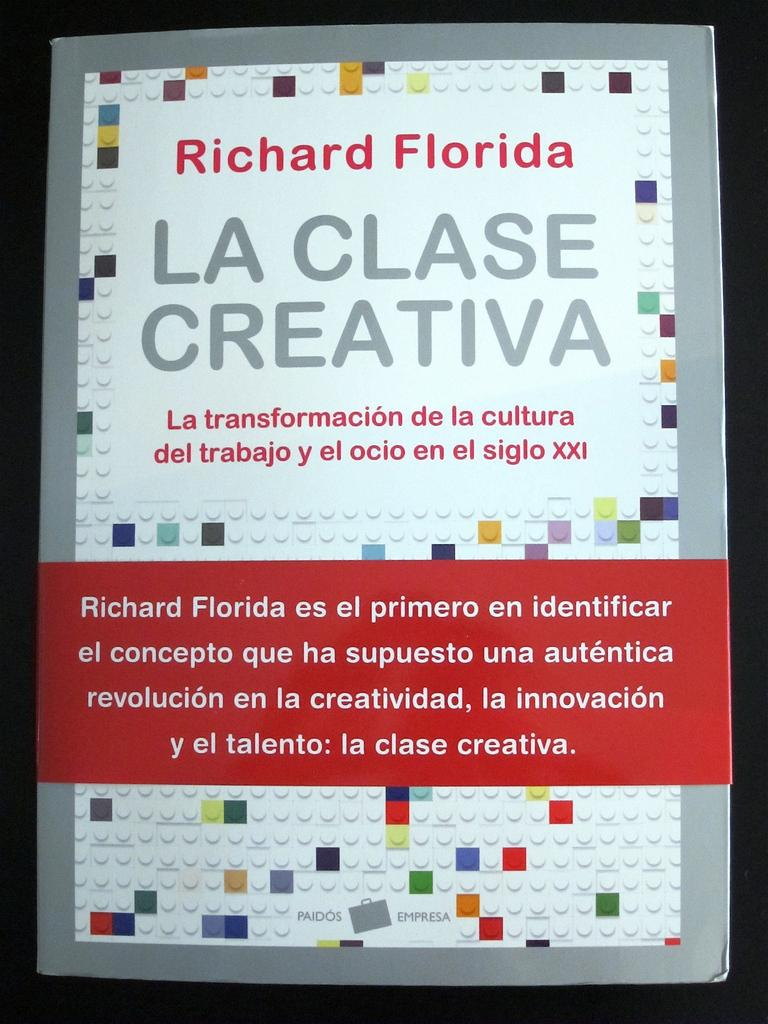<image>
Present a compact description of the photo's key features. a booklet with la clase creativa in it 